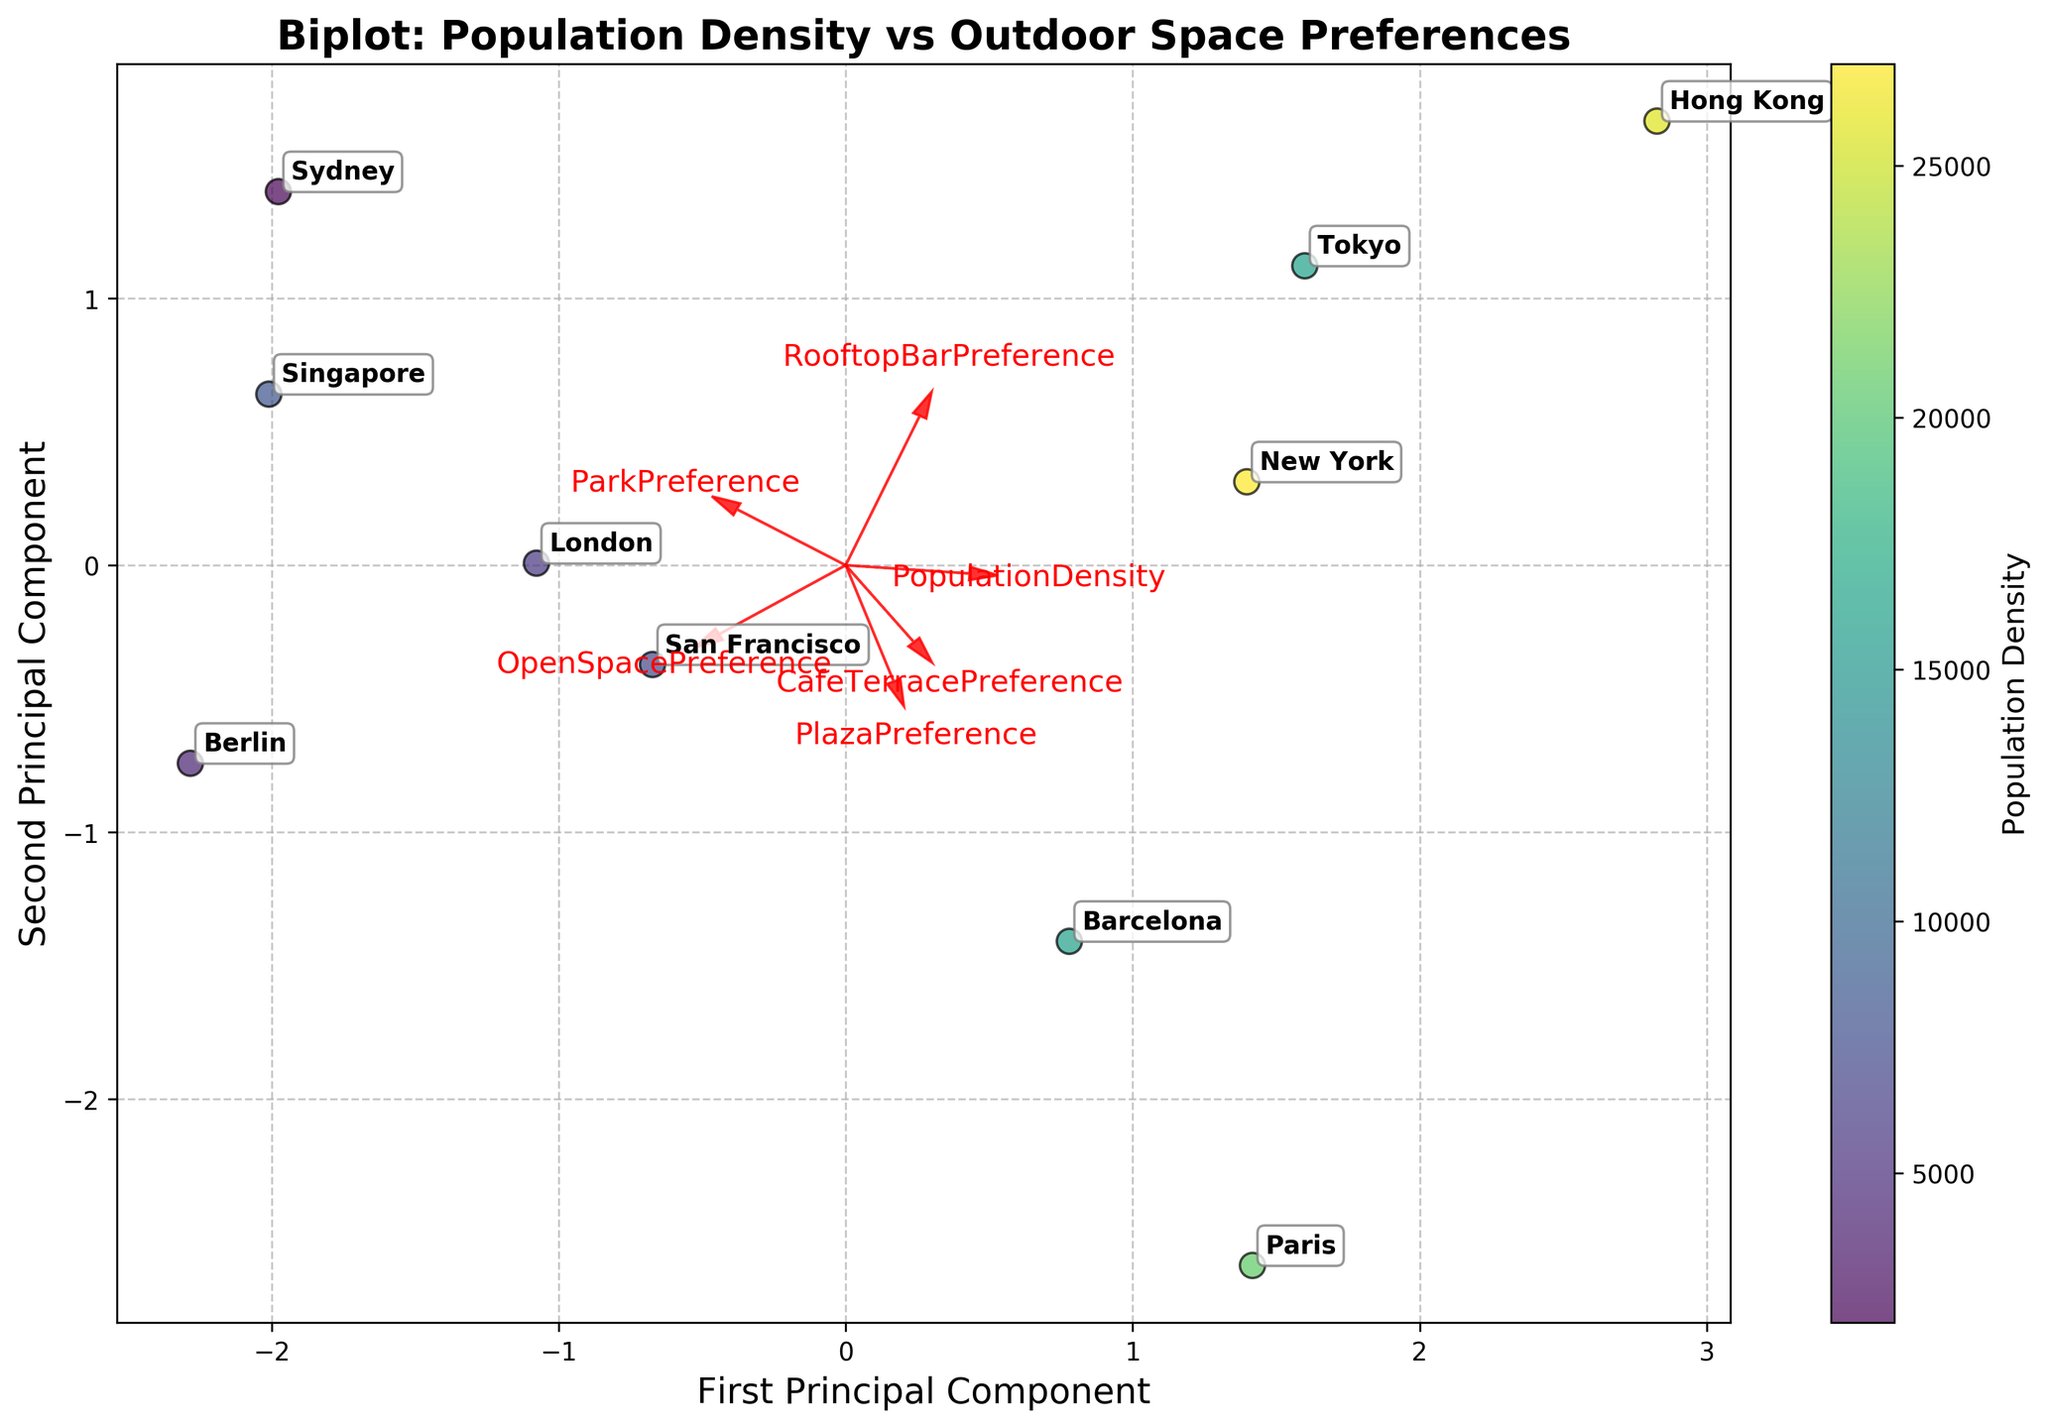What is the title of the biplot? The title is located at the top of the figure and summarizes the content of the plot. It mentions both "Population Density" and "Outdoor Space Preferences".
Answer: Biplot: Population Density vs Outdoor Space Preferences How many cities are represented on the biplot? You can count the number of unique city labels in the plot. Each city has its label next to its data point.
Answer: 10 Which city has the highest preference for cafe terraces, and how can you tell? Look for the city's label that is closest to the vector pointing in the direction of high "CafeTerracePreference" values. The vector represents the preference score direction.
Answer: New York Which city is located closest to the origin (0,0) in the PCA plot? Observe which city label is nearest to the central point where the two principal components intersect.
Answer: Tokyo Which feature has the most influence on the first principal component? Identify the feature vector that extends the farthest along the first (horizontal) principal component axis.
Answer: PopulationDensity What is the relationship between population density and park preference for the cities in the plot? Compare the positions of the cities in relation to the "PopulationDensity" and "ParkPreference" vectors. If the vectors are closely aligned or point in the same direction, they indicate a positive relationship.
Answer: Positive relationship Which city is most similar to New York in terms of outdoor gathering space preferences? Look for a city that is positioned closest to New York (label) in the PCA space; it represents similar characteristics in the context of outdoor preferences.
Answer: Paris Considering the vectors, which preference is more aligned with higher population density: park preference or rooftop bar preference? Compare the angles of the vectors "ParkPreference" and "RooftopBarPreference" with the "PopulationDensity" vector. The smaller the angle, the closer the alignment.
Answer: Rooftop Bar Preference Which two cities show the greatest difference in their positions on the biplot? The largest distance between any two city labels in the PCA plot represents the greatest difference. Measure or estimate visually.
Answer: Sydney and Paris What can be inferred about the preference for plazas versus open spaces in cities with moderate population density? Compare the angle between the "PlazaPreference" and "OpenSpacePreference" vectors relative to cities positioned near the middle of the population density color gradient.
Answer: Cities with moderate population density show varied preferences, not strongly aligned with either direction 